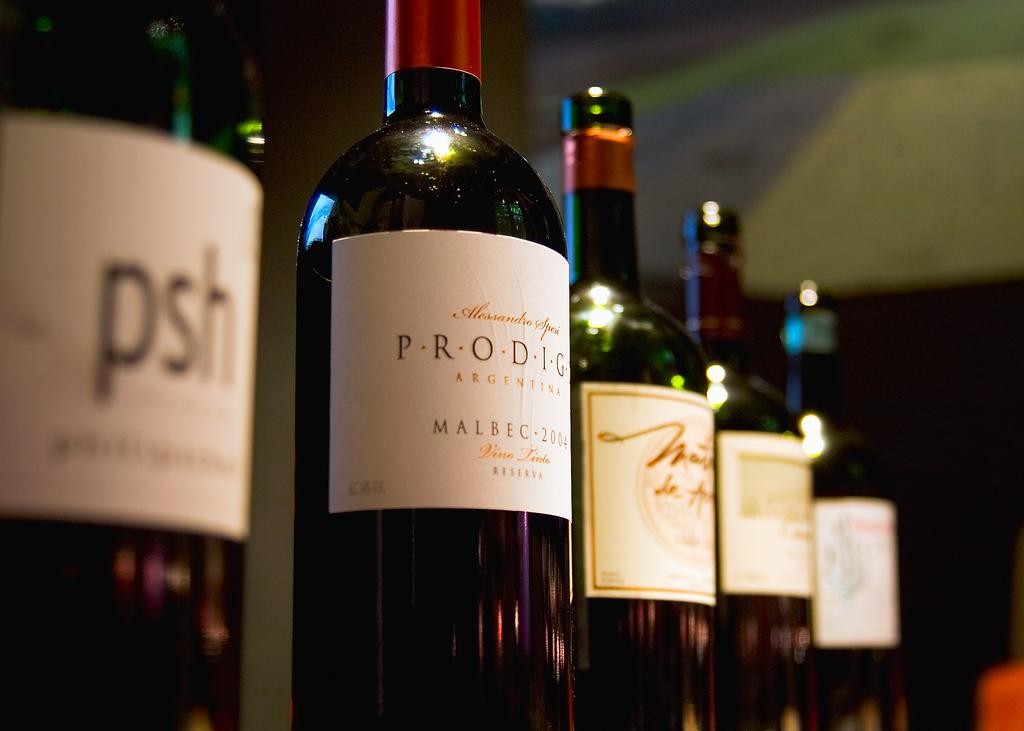<image>
Give a short and clear explanation of the subsequent image. Several bottles of red Malbec wine from Argentina 